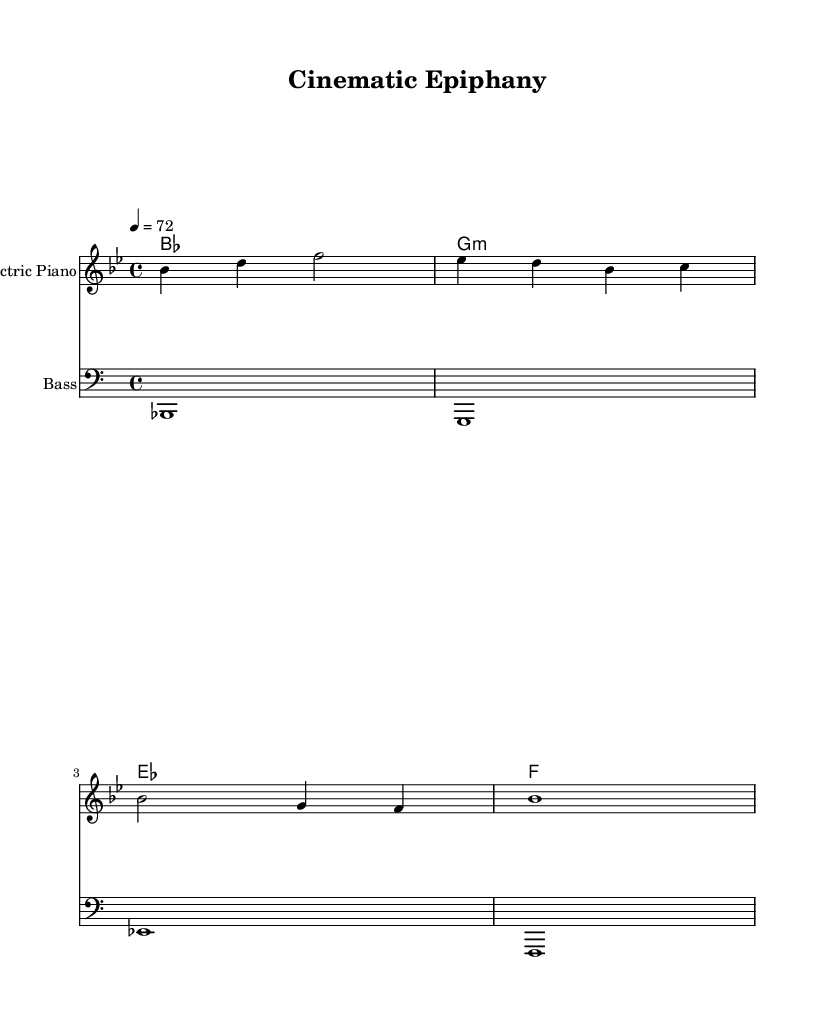What is the key signature of this music? The key signature is B-flat major, indicated by the presence of two flats (B-flat and E-flat) which are actually shown at the beginning of the staff.
Answer: B-flat major What is the time signature of this music? The time signature is shown at the beginning of the sheet music; it indicates that there are four beats in each measure, represented by the "4/4" marking.
Answer: 4/4 What is the tempo marking of the music? The tempo is indicated in beats per minute, specifically the marking shows "4 = 72", which means there are 72 beats in one minute.
Answer: 72 How many measures are in the melody? The melody is written in four measures, as indicated by the divisions in the sheet music, where each group of notes corresponds to one measure.
Answer: 4 What chord is played in the first measure? The first measure features a B-flat major chord, as shown by the chord names placed directly above the staff, indicating the harmonic structure.
Answer: B-flat How many distinct chords are used throughout the piece? By analyzing the chord changes in the harmony section, we see that there are four distinct chords for the entire piece: B-flat, G minor, E-flat, and F major.
Answer: 4 What instrument is noted for the melody? The sheet music explicitly states that the melody is to be played on an electric piano, as indicated in the staff labeling.
Answer: Electric Piano 